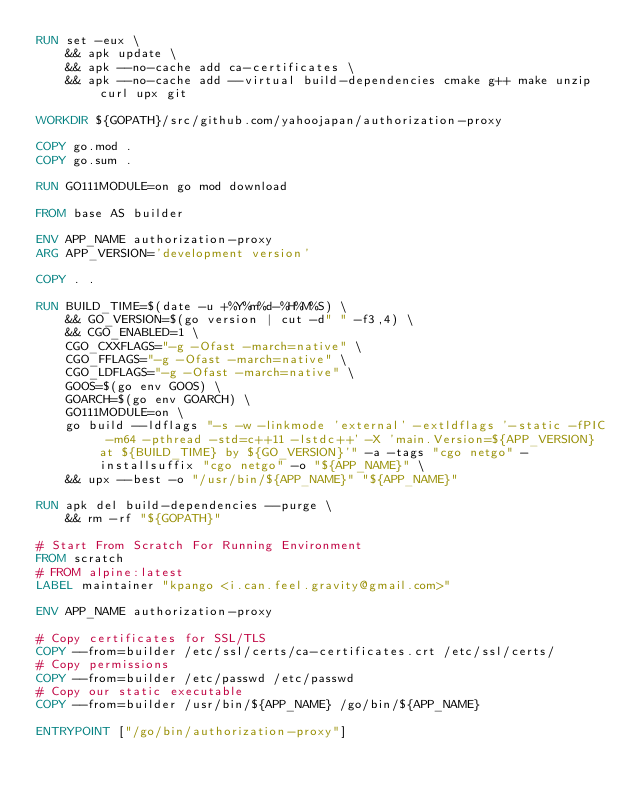Convert code to text. <code><loc_0><loc_0><loc_500><loc_500><_Dockerfile_>RUN set -eux \
    && apk update \
    && apk --no-cache add ca-certificates \
    && apk --no-cache add --virtual build-dependencies cmake g++ make unzip curl upx git

WORKDIR ${GOPATH}/src/github.com/yahoojapan/authorization-proxy

COPY go.mod .
COPY go.sum .

RUN GO111MODULE=on go mod download

FROM base AS builder

ENV APP_NAME authorization-proxy
ARG APP_VERSION='development version'

COPY . .

RUN BUILD_TIME=$(date -u +%Y%m%d-%H%M%S) \
    && GO_VERSION=$(go version | cut -d" " -f3,4) \
    && CGO_ENABLED=1 \
    CGO_CXXFLAGS="-g -Ofast -march=native" \
    CGO_FFLAGS="-g -Ofast -march=native" \
    CGO_LDFLAGS="-g -Ofast -march=native" \
    GOOS=$(go env GOOS) \
    GOARCH=$(go env GOARCH) \
    GO111MODULE=on \
    go build --ldflags "-s -w -linkmode 'external' -extldflags '-static -fPIC -m64 -pthread -std=c++11 -lstdc++' -X 'main.Version=${APP_VERSION} at ${BUILD_TIME} by ${GO_VERSION}'" -a -tags "cgo netgo" -installsuffix "cgo netgo" -o "${APP_NAME}" \
    && upx --best -o "/usr/bin/${APP_NAME}" "${APP_NAME}"

RUN apk del build-dependencies --purge \
    && rm -rf "${GOPATH}"

# Start From Scratch For Running Environment
FROM scratch
# FROM alpine:latest
LABEL maintainer "kpango <i.can.feel.gravity@gmail.com>"

ENV APP_NAME authorization-proxy

# Copy certificates for SSL/TLS
COPY --from=builder /etc/ssl/certs/ca-certificates.crt /etc/ssl/certs/
# Copy permissions
COPY --from=builder /etc/passwd /etc/passwd
# Copy our static executable
COPY --from=builder /usr/bin/${APP_NAME} /go/bin/${APP_NAME}

ENTRYPOINT ["/go/bin/authorization-proxy"]
</code> 